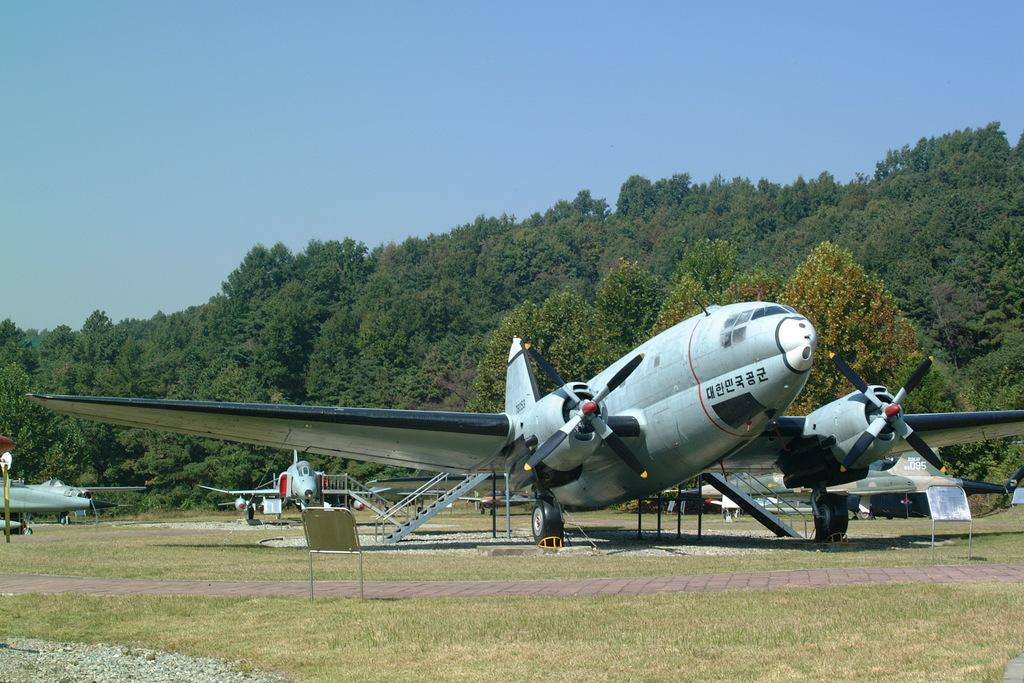What is the main subject of the picture? The main subject of the picture is airplanes. What can be seen in the foreground of the image? There is grass in the foreground of the image. What type of vegetation is visible in the background of the image? There are trees in the background of the image. What is the condition of the sky in the picture? The sky is clear in the image. How many kittens are playing with the goose in the image? There are no kittens or geese present in the image; it features airplanes, grass, trees, and a clear sky. What time of day is depicted in the image? The provided facts do not specify the time of day, so it cannot be determined from the image. 